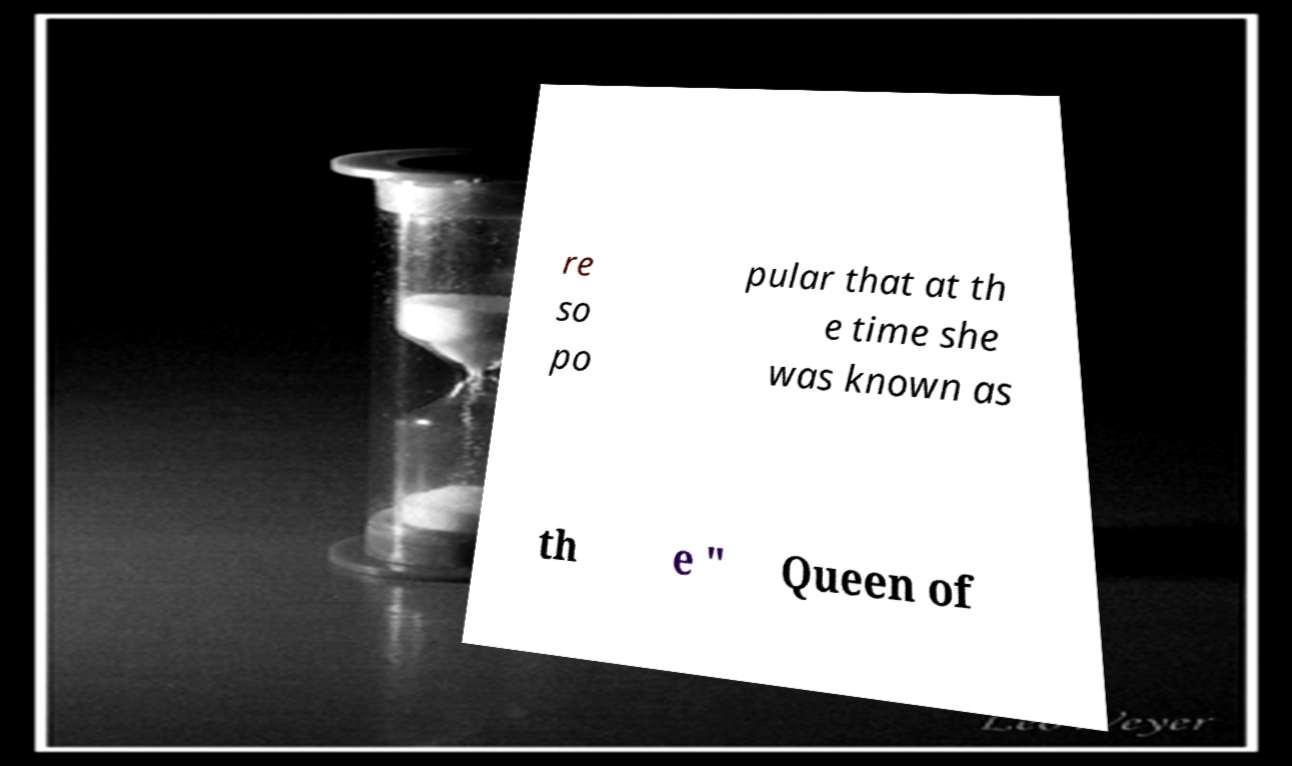I need the written content from this picture converted into text. Can you do that? re so po pular that at th e time she was known as th e " Queen of 